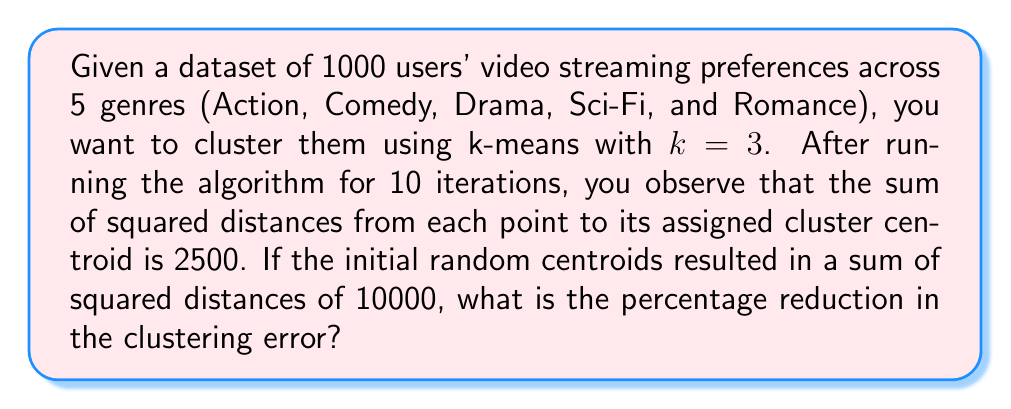Show me your answer to this math problem. To solve this problem, we need to follow these steps:

1. Identify the initial clustering error:
   Initial sum of squared distances = 10000

2. Identify the final clustering error after 10 iterations:
   Final sum of squared distances = 2500

3. Calculate the reduction in clustering error:
   Error reduction = Initial error - Final error
   $$ \text{Error reduction} = 10000 - 2500 = 7500 $$

4. Calculate the percentage reduction:
   Percentage reduction = (Error reduction / Initial error) × 100%
   $$ \text{Percentage reduction} = \frac{7500}{10000} \times 100\% = 0.75 \times 100\% = 75\% $$

Therefore, the percentage reduction in the clustering error is 75%.
Answer: 75% 